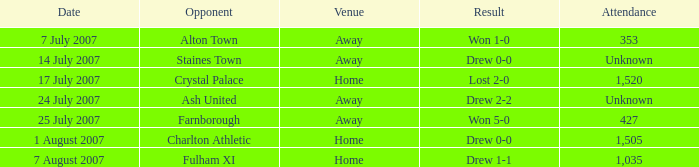On which date did the winning team achieve a 1-0 result? 7 July 2007. 